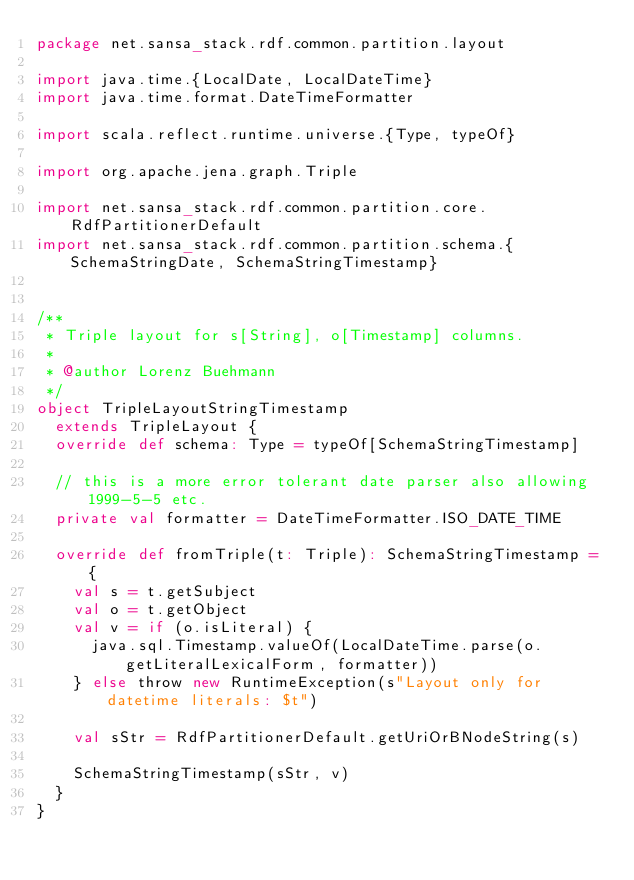<code> <loc_0><loc_0><loc_500><loc_500><_Scala_>package net.sansa_stack.rdf.common.partition.layout

import java.time.{LocalDate, LocalDateTime}
import java.time.format.DateTimeFormatter

import scala.reflect.runtime.universe.{Type, typeOf}

import org.apache.jena.graph.Triple

import net.sansa_stack.rdf.common.partition.core.RdfPartitionerDefault
import net.sansa_stack.rdf.common.partition.schema.{SchemaStringDate, SchemaStringTimestamp}


/**
 * Triple layout for s[String], o[Timestamp] columns.
 *
 * @author Lorenz Buehmann
 */
object TripleLayoutStringTimestamp
  extends TripleLayout {
  override def schema: Type = typeOf[SchemaStringTimestamp]

  // this is a more error tolerant date parser also allowing 1999-5-5 etc.
  private val formatter = DateTimeFormatter.ISO_DATE_TIME

  override def fromTriple(t: Triple): SchemaStringTimestamp = {
    val s = t.getSubject
    val o = t.getObject
    val v = if (o.isLiteral) {
      java.sql.Timestamp.valueOf(LocalDateTime.parse(o.getLiteralLexicalForm, formatter))
    } else throw new RuntimeException(s"Layout only for datetime literals: $t")

    val sStr = RdfPartitionerDefault.getUriOrBNodeString(s)

    SchemaStringTimestamp(sStr, v)
  }
}
</code> 